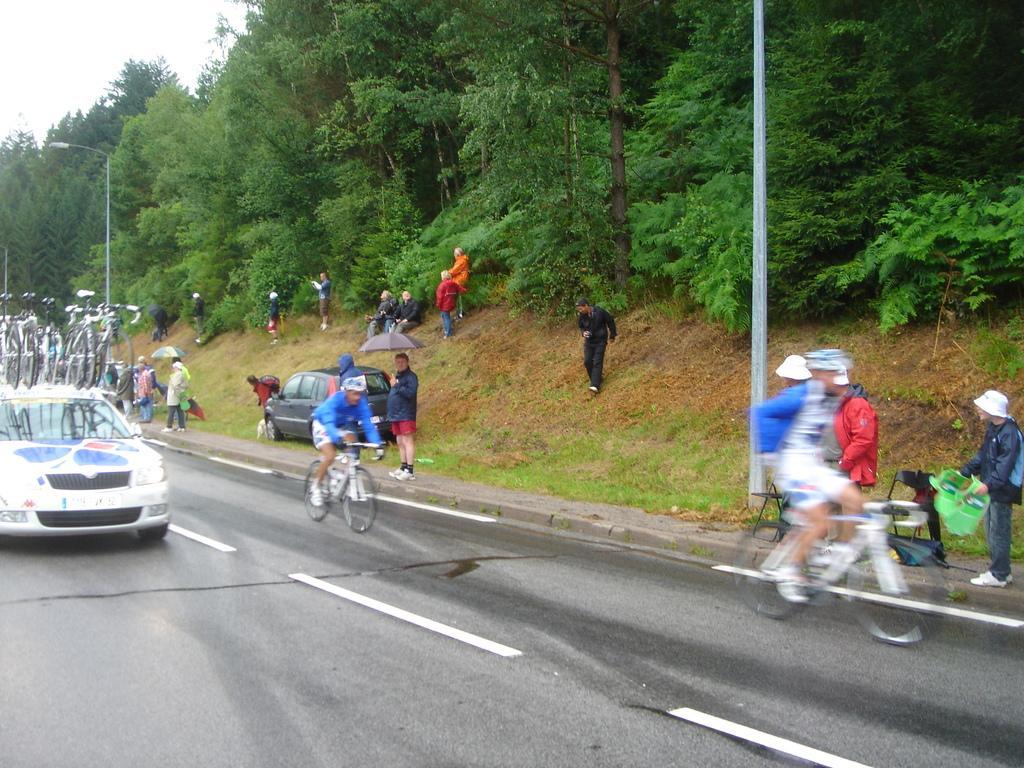Please provide a concise description of this image. Few persons are standing and few persons are sitting and these two persons are riding bicycle and wear helmet. We can see car on the road. We can see trees and sky. 